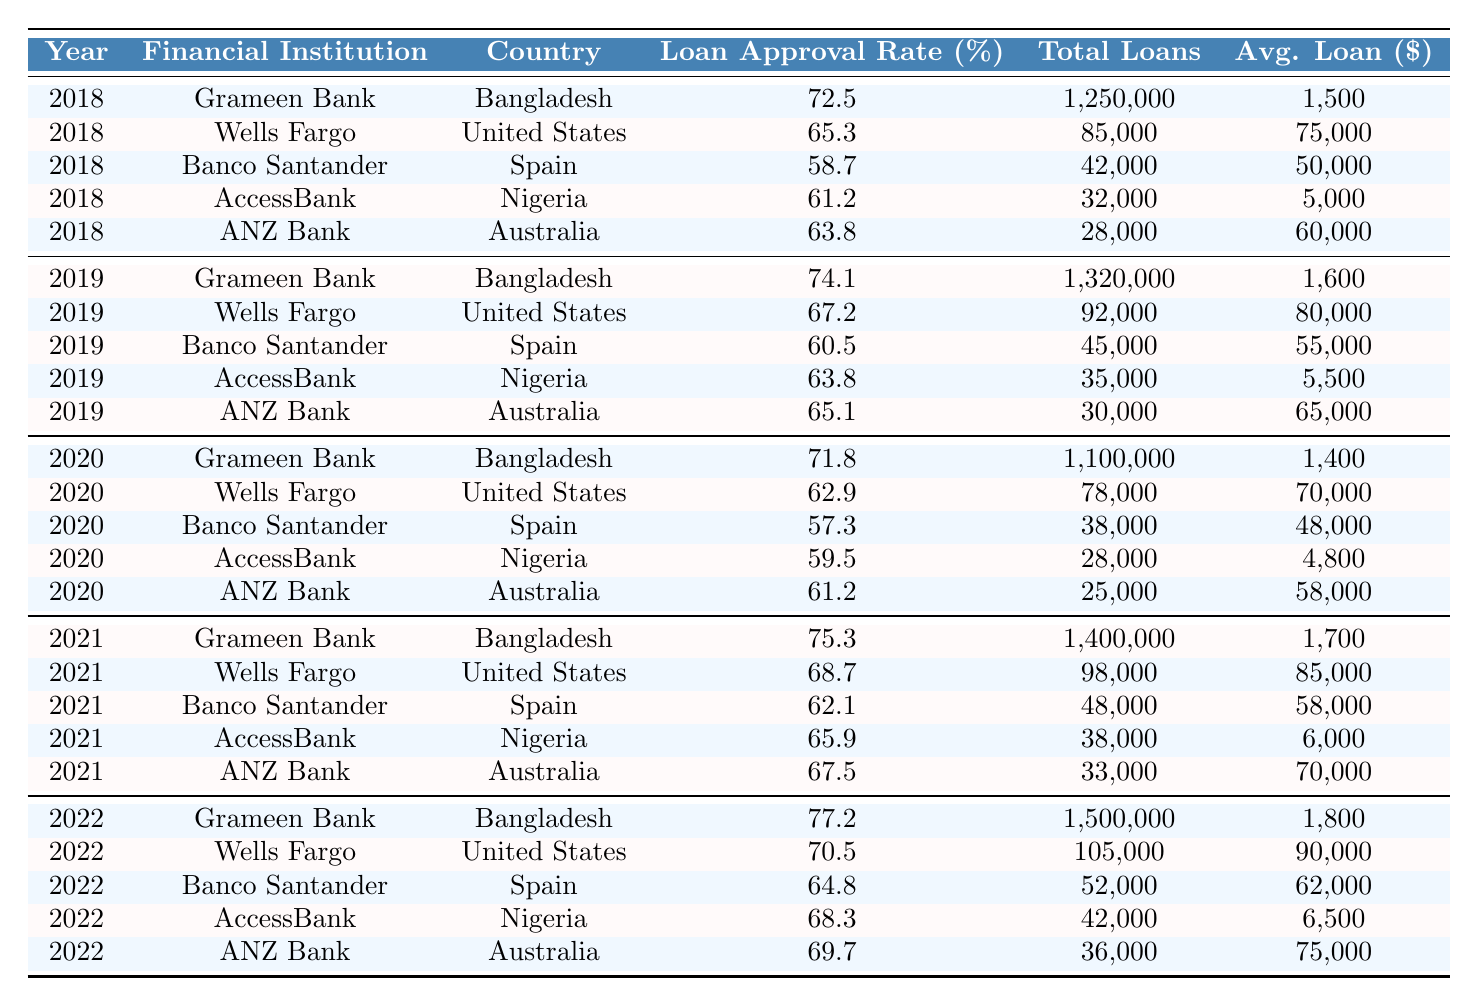What was the loan approval rate for women entrepreneurs by Grameen Bank in 2022? In 2022, the loan approval rate for women entrepreneurs by Grameen Bank is explicitly provided in the table, which states it as 77.2%.
Answer: 77.2% Which financial institution had the highest loan approval rate in 2021? By examining the table, the loan approval rates for 2021 are 75.3% for Grameen Bank, 68.7% for Wells Fargo, 62.1% for Banco Santander, 65.9% for AccessBank, and 67.5% for ANZ Bank. The highest among these is 75.3% at Grameen Bank.
Answer: Grameen Bank What was the average loan amount approved for women entrepreneurs by Wells Fargo across all years? To find the average loan amount by Wells Fargo, we take the amounts from each year (75,000 in 2018, 80,000 in 2019, 70,000 in 2020, 85,000 in 2021, and 90,000 in 2022). Adding these amounts gives 400,000 and dividing by the number of years (5) gives an average of 80,000.
Answer: 80,000 Was there a decline in the loan approval rate for women entrepreneurs at Banco Santander from 2018 to 2020? The loan approval rates for Banco Santander are 58.7% in 2018, 60.5% in 2019, and 57.3% in 2020. From 2018 to 2019, there was an increase, but from 2019 to 2020, it did decline. So yes, there was a decline from 60.5% to 57.3%.
Answer: Yes Which country had the lowest average loan approval rate for women entrepreneurs over the five years? The average loan approval rates for each country can be calculated from the data: Bangladesh (74.38%), United States (66.53%), Spain (61.12%), Nigeria (63.36%), and Australia (65.84%). The lowest average is for Banco Santander in Spain at 61.12%.
Answer: Spain For which financial institution did the total loans approved for women entrepreneurs increase the most from 2018 to 2022? We can compare total loans approved for each institution from 2018 to 2022: Grameen Bank (1,250,000 to 1,500,000), Wells Fargo (85,000 to 105,000), Banco Santander (42,000 to 52,000), AccessBank (32,000 to 42,000), and ANZ Bank (28,000 to 36,000). Grameen Bank saw the largest increase of 250,000.
Answer: Grameen Bank Is it true that the average loan amount for women entrepreneurs generally increased over the years for ANZ Bank? The average loan amounts for ANZ Bank across the years are 60,000 (2018), 65,000 (2019), 58,000 (2020), 70,000 (2021), and 75,000 (2022). From the years 2018 to 2020, there was a decline, but from 2020 to 2022, it increased. Therefore, the statement is not entirely true.
Answer: No 